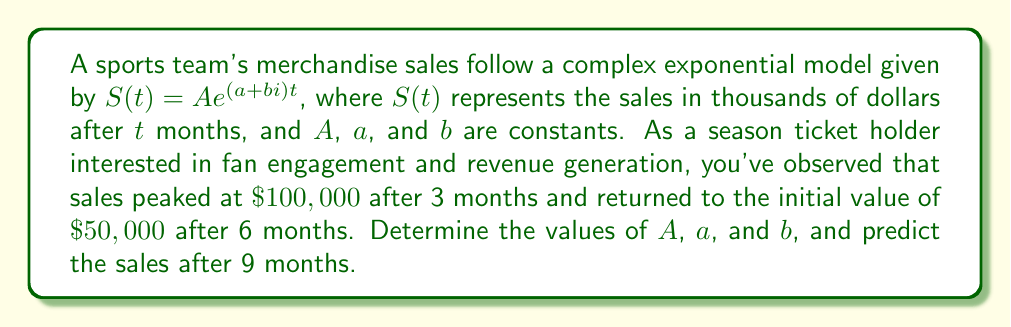Solve this math problem. Let's approach this step-by-step:

1) We're given that $S(t) = Ae^{(a+bi)t}$. We need to find $A$, $a$, and $b$.

2) We know three points:
   At $t=0$: $S(0) = A = 50$
   At $t=3$: $S(3) = 50e^{3(a+bi)} = 100$
   At $t=6$: $S(6) = 50e^{6(a+bi)} = 50$

3) From $S(3)$, we can write:
   $$e^{3(a+bi)} = 2$$

4) Taking the natural log of both sides:
   $$3(a+bi) = \ln 2 + 2\pi ni$$ where $n$ is an integer

5) From $S(6)$, we can write:
   $$e^{6(a+bi)} = 1$$

6) Taking the natural log:
   $$6(a+bi) = 2\pi mi$$ where $m$ is an integer

7) From steps 4 and 5:
   $$a = \frac{\ln 2}{3}, \quad b = \frac{2\pi n}{3}$$
   $$a = 0, \quad b = \frac{\pi m}{3}$$

8) For these to be consistent, we must have:
   $$\frac{\ln 2}{3} = 0 \quad \text{and} \quad \frac{2\pi n}{3} = \frac{\pi m}{3}$$

9) The first equation is not true, so we need to consider complex logarithms. The general solution is:
   $$6(a+bi) = 2\pi i$$

10) Solving this:
    $$a = 0, \quad b = \frac{\pi}{3}$$

11) To predict sales after 9 months, we use:
    $$S(9) = 50e^{9(0+\frac{\pi i}{3})} = 50(\cos 3\pi + i \sin 3\pi) = 50(-1) = -50$$

12) The negative sign indicates that sales have reversed direction, meaning the company owes $\$50,000$ in returns or adjustments.
Answer: $A = 50$, $a = 0$, $b = \frac{\pi}{3}$. Predicted sales after 9 months: $-\$50,000$ (indicating $\$50,000$ in returns or adjustments). 